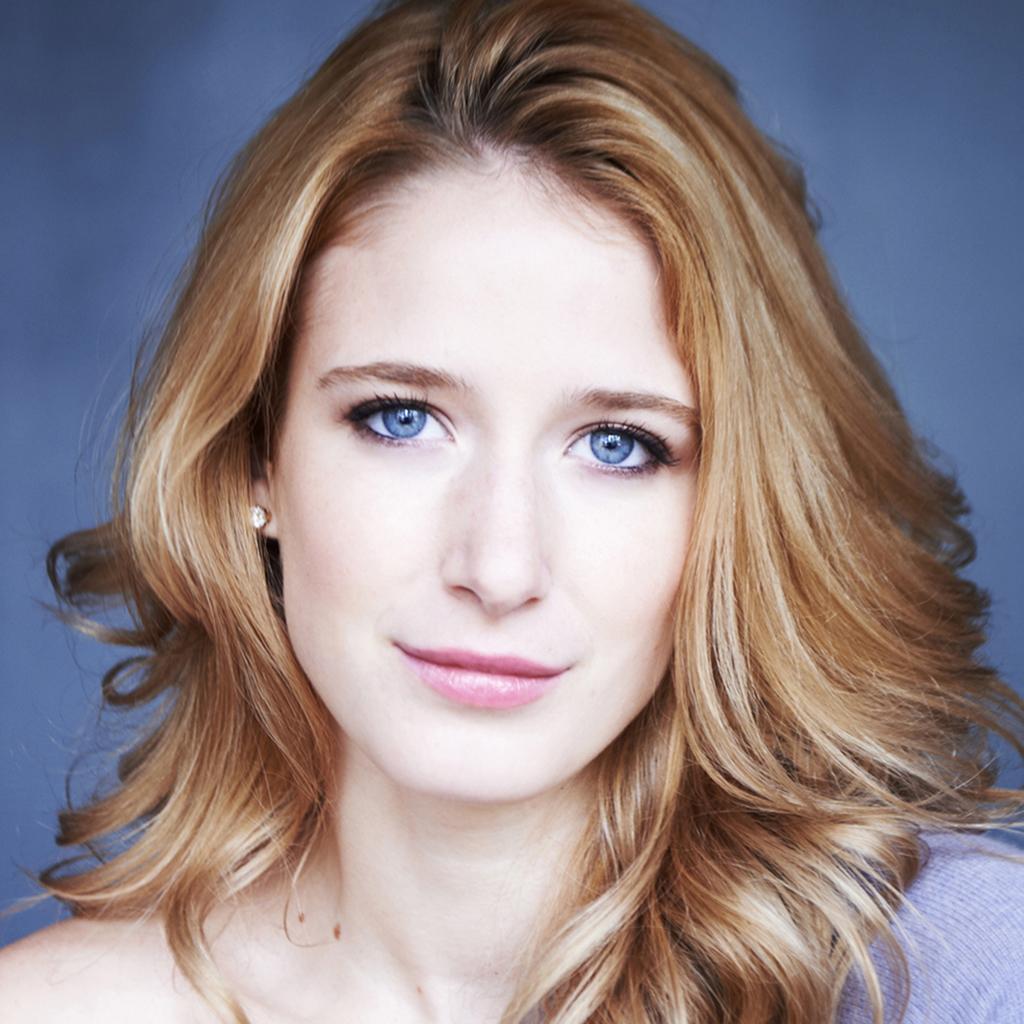Who is present in the image? There is a lady in the image. What can be seen behind the lady? There is a background visible in the image. What type of comfort can be seen in the image? There is no specific type of comfort visible in the image. Is there a cast visible on the lady in the image? There is no cast visible on the lady in the image. Is there a lock present in the image? There is no lock present in the image. 